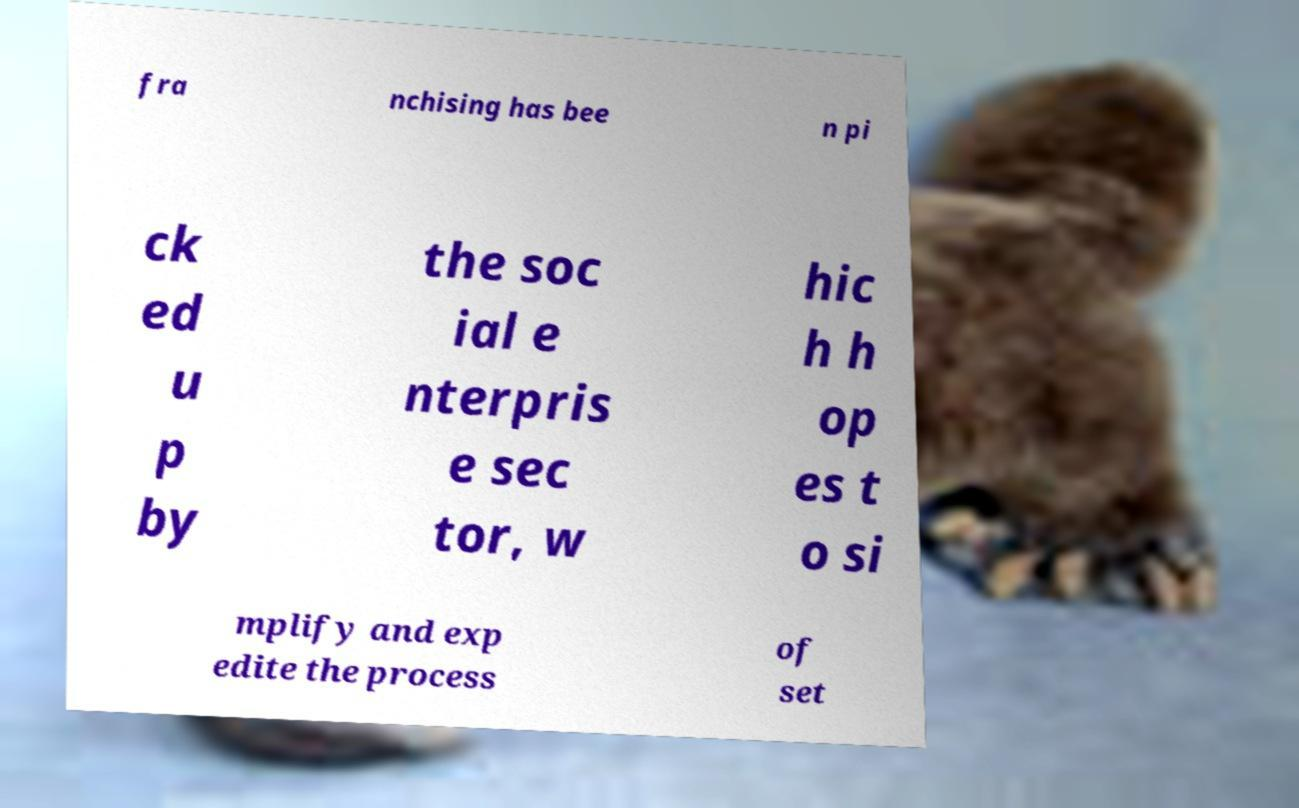Please read and relay the text visible in this image. What does it say? fra nchising has bee n pi ck ed u p by the soc ial e nterpris e sec tor, w hic h h op es t o si mplify and exp edite the process of set 